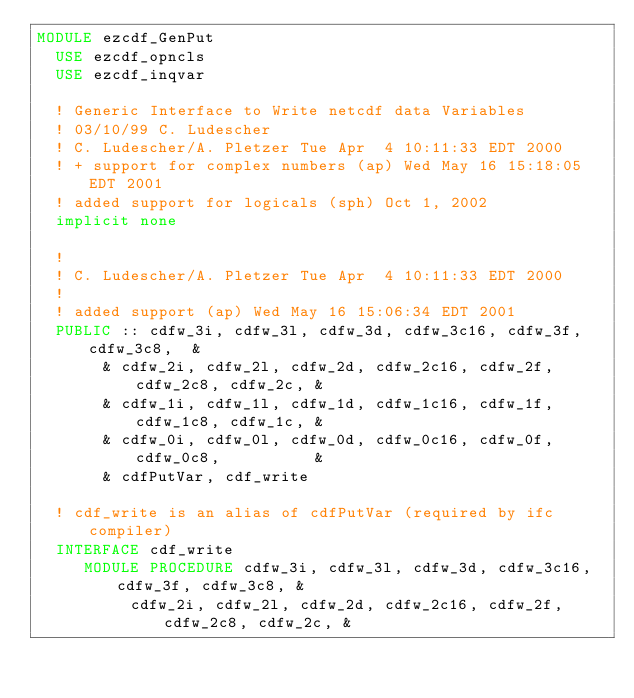<code> <loc_0><loc_0><loc_500><loc_500><_FORTRAN_>MODULE ezcdf_GenPut
  USE ezcdf_opncls
  USE ezcdf_inqvar

  ! Generic Interface to Write netcdf data Variables
  ! 03/10/99 C. Ludescher
  ! C. Ludescher/A. Pletzer Tue Apr  4 10:11:33 EDT 2000
  ! + support for complex numbers (ap) Wed May 16 15:18:05 EDT 2001
  ! added support for logicals (sph) Oct 1, 2002
  implicit none

  !
  ! C. Ludescher/A. Pletzer Tue Apr  4 10:11:33 EDT 2000
  !
  ! added support (ap) Wed May 16 15:06:34 EDT 2001
  PUBLIC :: cdfw_3i, cdfw_3l, cdfw_3d, cdfw_3c16, cdfw_3f, cdfw_3c8,  &
       & cdfw_2i, cdfw_2l, cdfw_2d, cdfw_2c16, cdfw_2f, cdfw_2c8, cdfw_2c, &
       & cdfw_1i, cdfw_1l, cdfw_1d, cdfw_1c16, cdfw_1f, cdfw_1c8, cdfw_1c, &
       & cdfw_0i, cdfw_0l, cdfw_0d, cdfw_0c16, cdfw_0f, cdfw_0c8,          &
       & cdfPutVar, cdf_write

  ! cdf_write is an alias of cdfPutVar (required by ifc compiler)
  INTERFACE cdf_write
     MODULE PROCEDURE cdfw_3i, cdfw_3l, cdfw_3d, cdfw_3c16, cdfw_3f, cdfw_3c8, &
          cdfw_2i, cdfw_2l, cdfw_2d, cdfw_2c16, cdfw_2f, cdfw_2c8, cdfw_2c, &</code> 